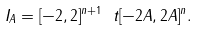<formula> <loc_0><loc_0><loc_500><loc_500>I _ { A } = [ - 2 , 2 ] ^ { n + 1 } \ t [ - 2 A , 2 A ] ^ { n } .</formula> 